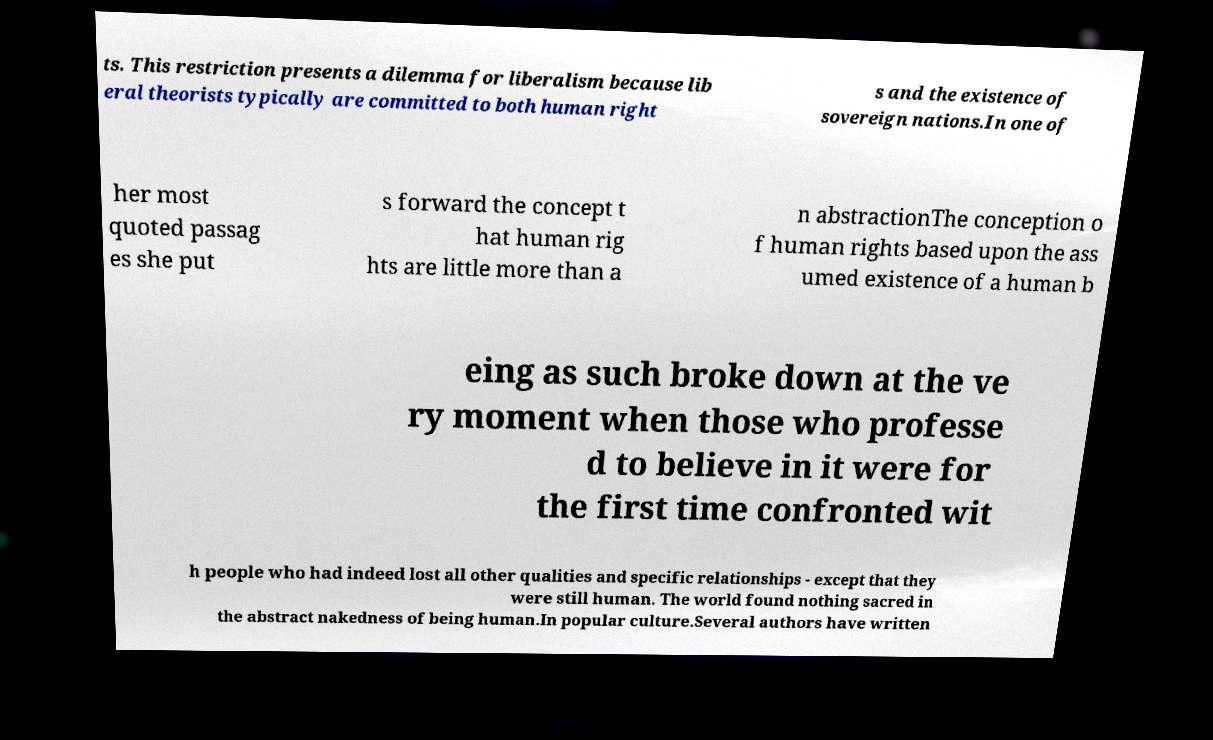Could you extract and type out the text from this image? ts. This restriction presents a dilemma for liberalism because lib eral theorists typically are committed to both human right s and the existence of sovereign nations.In one of her most quoted passag es she put s forward the concept t hat human rig hts are little more than a n abstractionThe conception o f human rights based upon the ass umed existence of a human b eing as such broke down at the ve ry moment when those who professe d to believe in it were for the first time confronted wit h people who had indeed lost all other qualities and specific relationships - except that they were still human. The world found nothing sacred in the abstract nakedness of being human.In popular culture.Several authors have written 